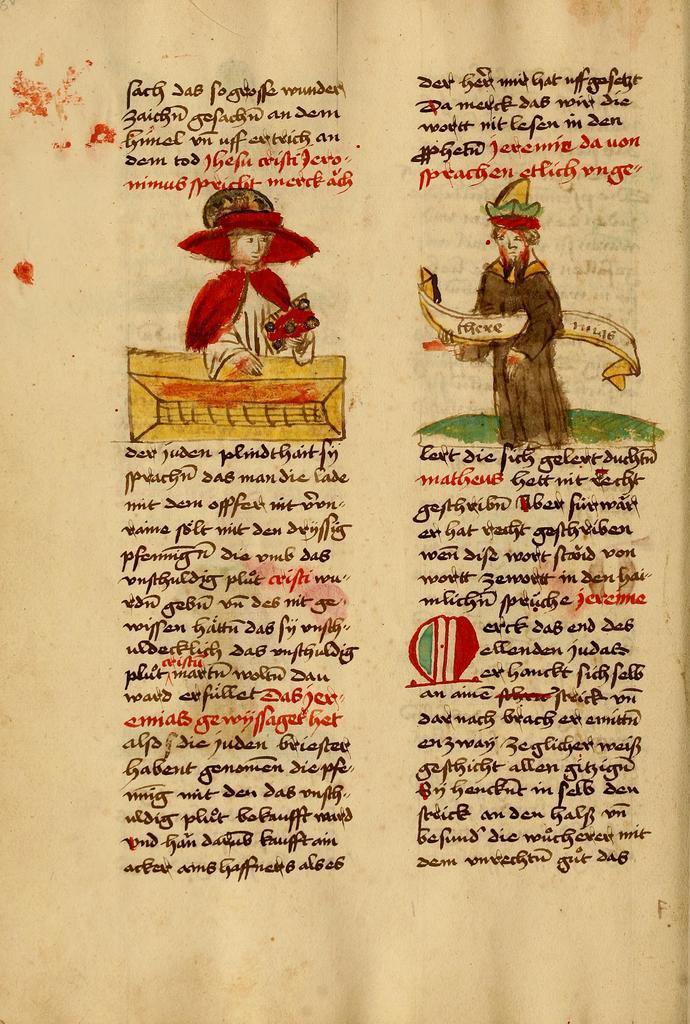In one or two sentences, can you explain what this image depicts? In this image, we can see a paper contains depiction of persons and some written text. 